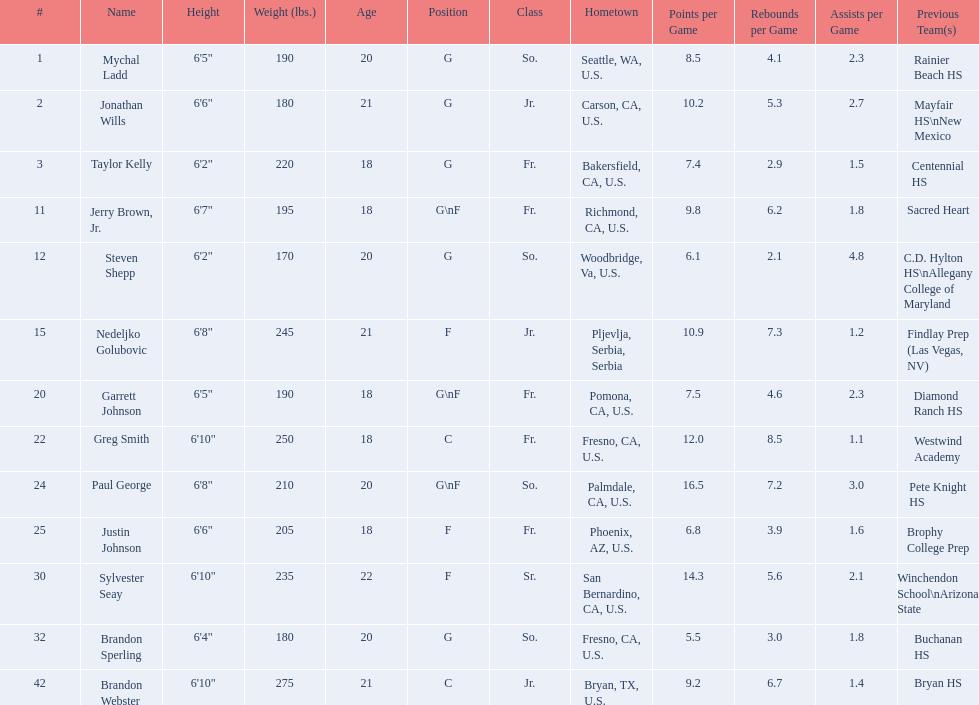What class was each team member in for the 2009-10 fresno state bulldogs? So., Jr., Fr., Fr., So., Jr., Fr., Fr., So., Fr., Sr., So., Jr. Which of these was outside of the us? Jr. Who was the player? Nedeljko Golubovic. 